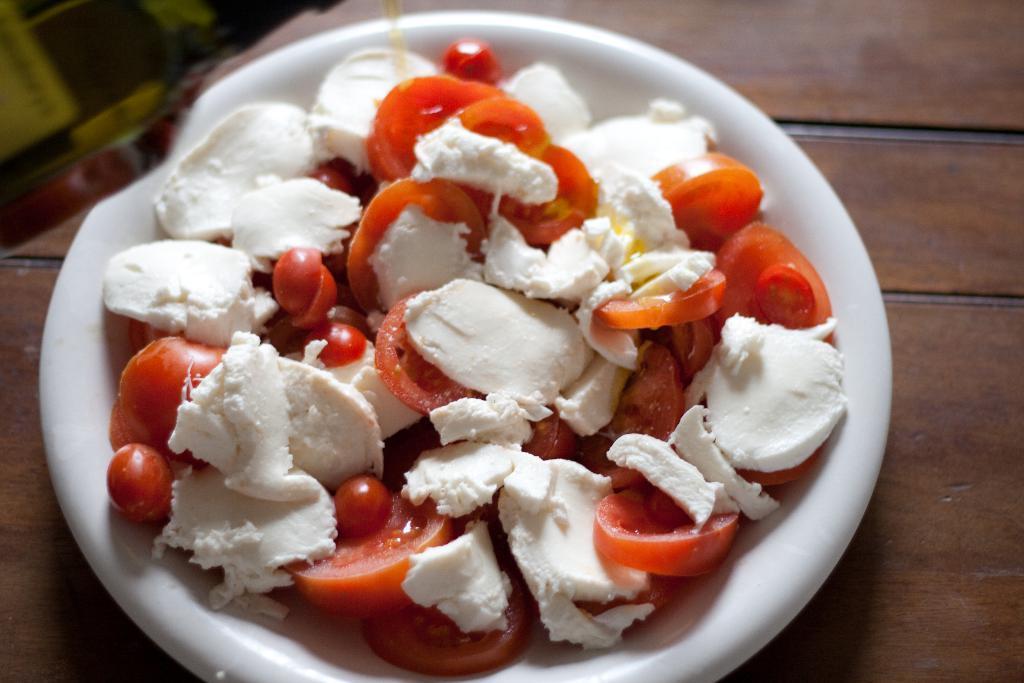Could you give a brief overview of what you see in this image? In the center of the image we can see one table. On the table, we can see one plate. In the plate, we can see some food items. At the top left side of the image, we can see some object. 